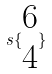Convert formula to latex. <formula><loc_0><loc_0><loc_500><loc_500>s \{ \begin{matrix} 6 \\ 4 \end{matrix} \}</formula> 